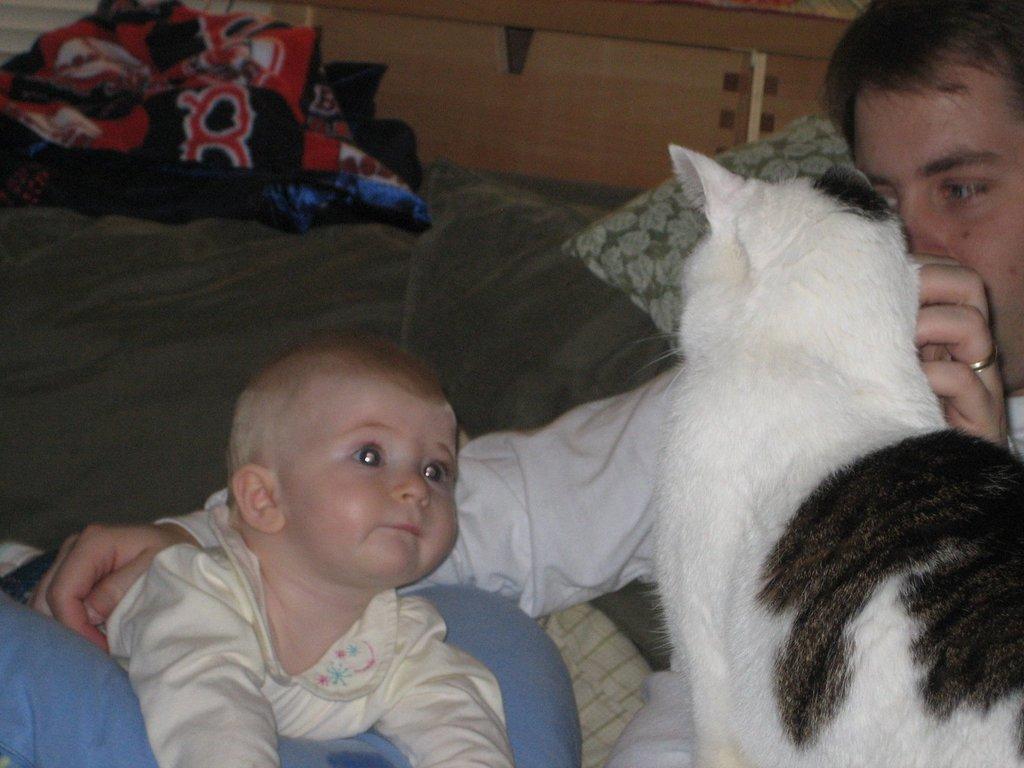Describe this image in one or two sentences. In the image there is a baby beside that there is a man,he is holding a cat in his hand,the baby is looking at the cat,in the background there is a bed sheet,pillow and wooden cupboard. 